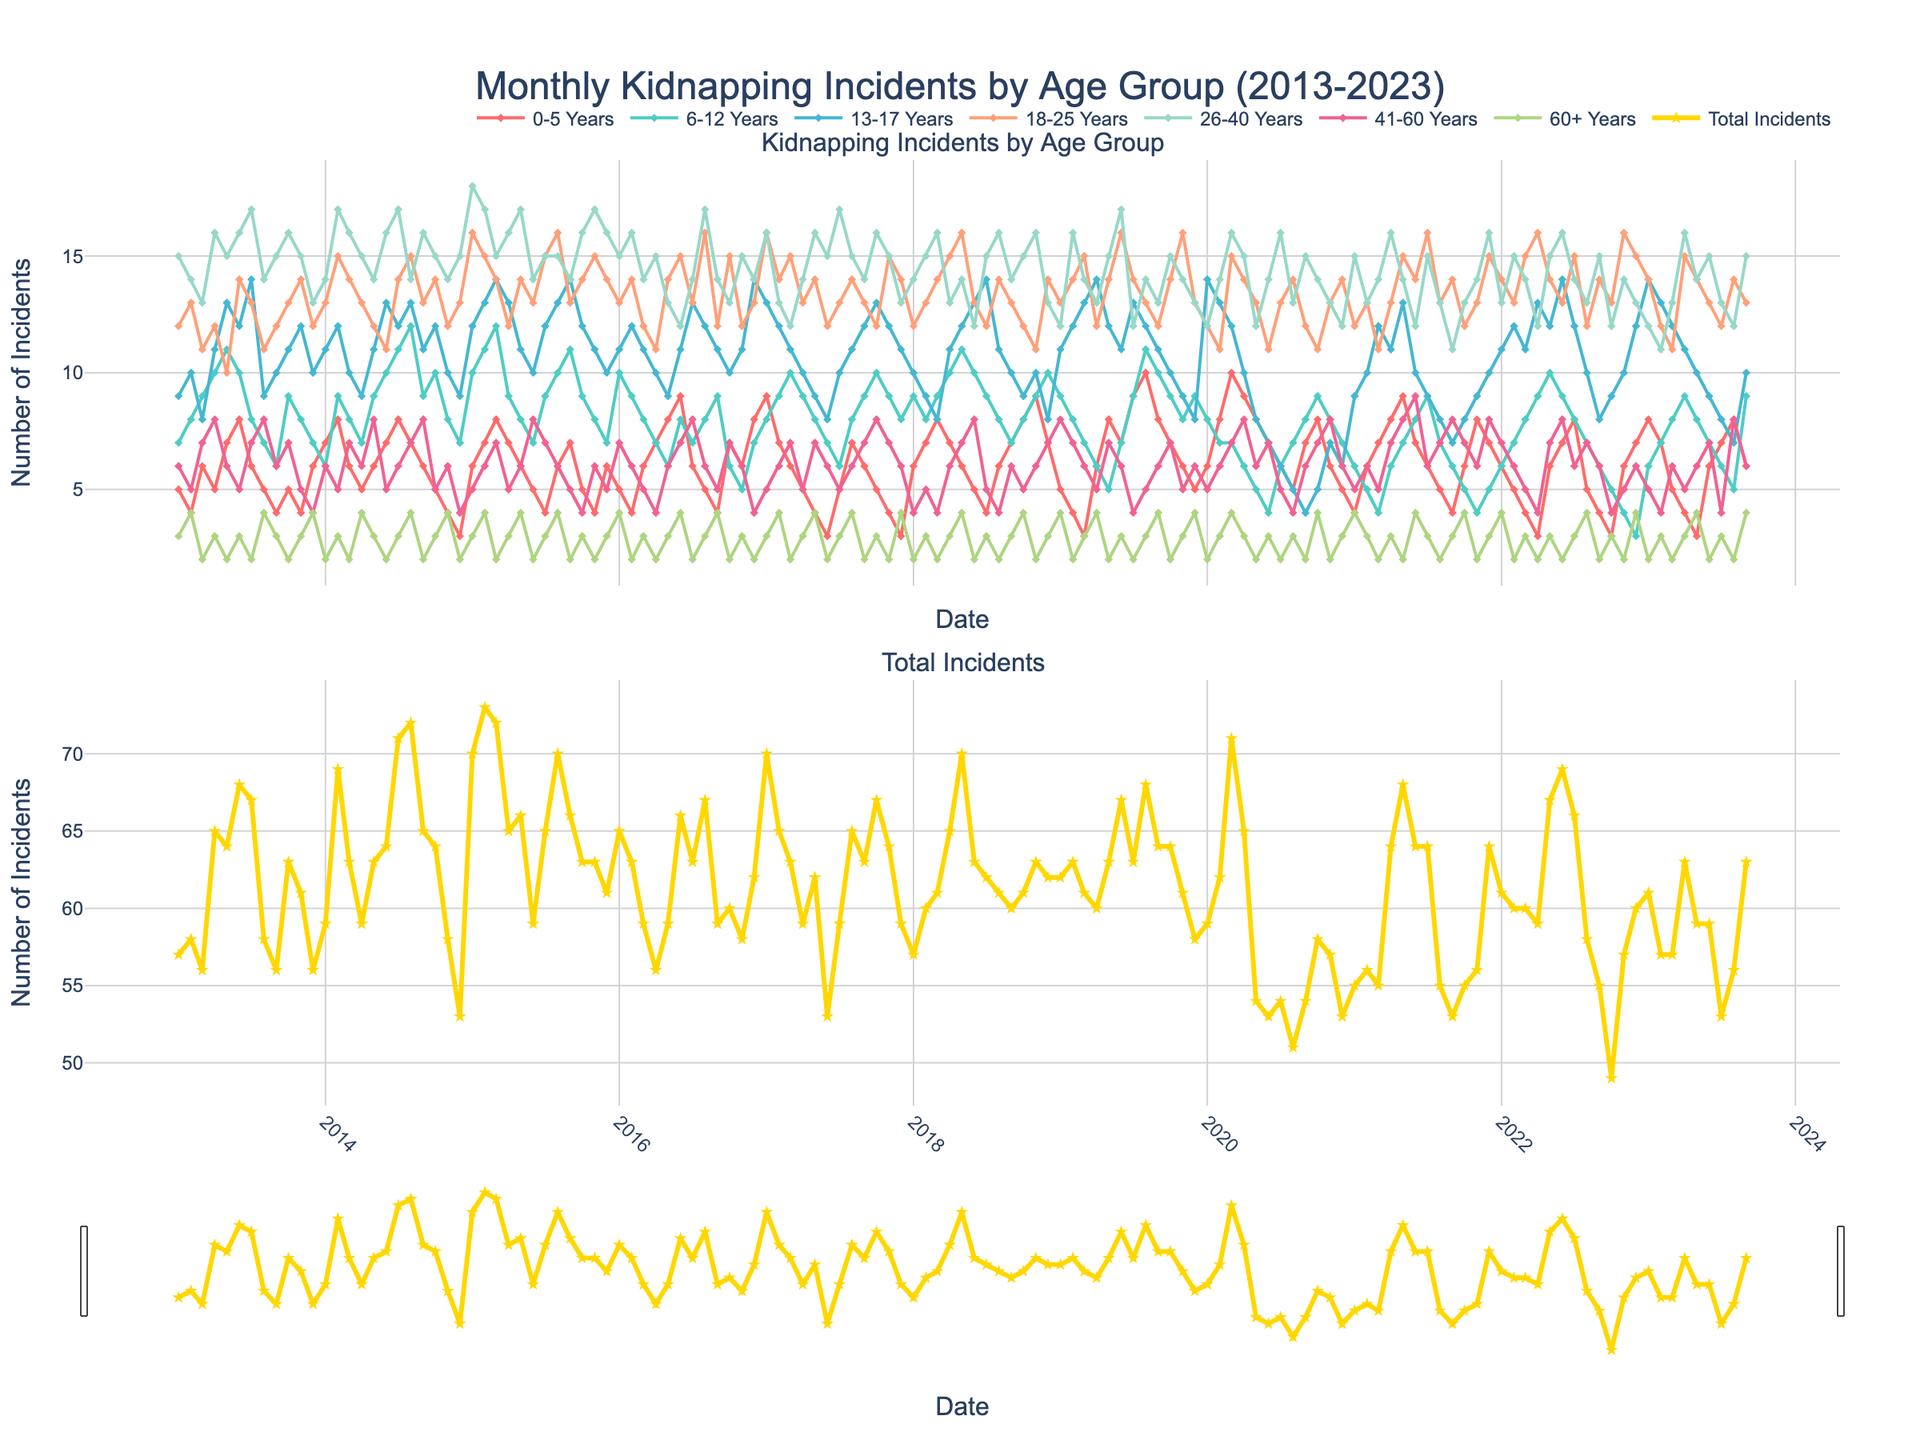What does the title of the figure indicate? The title "Monthly Kidnapping Incidents by Age Group (2013-2023)" indicates that the figure shows the number of kidnapping incidents monthly over a 10-year period, divided by different age groups.
Answer: It shows monthly kidnapping incidents by age group over a 10-year period How many age groups are represented in the figure, and what are they? The figure represents seven age groups: 0-5 Years, 6-12 Years, 13-17 Years, 18-25 Years, 26-40 Years, 41-60 Years, and 60+ Years, each plotted with different colored lines.
Answer: Seven age groups Which age group had the highest peak in kidnapping incidents, and when did it occur? By observing the peaks in the lines, the age group 18-25 Years had the highest peak, occurring around January 2015.
Answer: 18-25 Years, January 2015 What is the range of the y-axis for the total incidents subplot? The y-axis range for the total incidents subplot varies roughly from 0 to 90, as indicated by the highest peaks in the second subplot.
Answer: 0 to 90 In which year did the total number of incidents hit its maximum, and during which month? Observing the total number of incidents line in the second subplot, the maximum occurred around March 2020.
Answer: March 2020 Which age group shows the most consistent trend over the decade? The 60+ Years age group shows a relatively consistent trend with fewer fluctuations compared to the other age groups in the plot.
Answer: 60+ Years How does the trend in the age group 13-17 Years compare to the trend in the age group 41-60 Years? The trend for 13-17 Years has more fluctuations with occasional high peaks, while the trend for 41-60 Years is more stable with moderate peaks throughout the decade.
Answer: 13-17 Years has more fluctuations Did any age group see a significant increase in incidents around 2020? The 13-17 Years and 18-25 Years age groups saw noticeable increases in incidents around the year 2020, visible as rising lines at that time.
Answer: 13-17 Years and 18-25 Years What is the overall trend observed in the total kidnapping incidents over the decade? The total kidnapping incidents show some periodic ups and downs, with a few peaks around significant years, but no clear linear trend can be determined just from visual inspection.
Answer: Periodic ups and downs Which age group had the lowest number of incidents in December 2019? By examining the lines for December 2019, the 60+ Years age group had the lowest number of incidents compared to the other age groups.
Answer: 60+ Years 